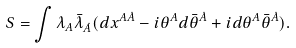Convert formula to latex. <formula><loc_0><loc_0><loc_500><loc_500>S = \int \lambda _ { A } \bar { \lambda } _ { \dot { A } } ( d x ^ { A \dot { A } } - i \theta ^ { A } d \bar { \theta } ^ { \dot { A } } + i d \theta ^ { A } \bar { \theta } ^ { \dot { A } } ) .</formula> 